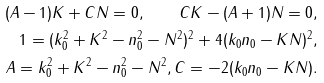Convert formula to latex. <formula><loc_0><loc_0><loc_500><loc_500>( A - 1 ) K + C N = 0 , \quad C K - ( A + 1 ) N = 0 , \\ 1 = ( k _ { 0 } ^ { 2 } + K ^ { 2 } - n _ { 0 } ^ { 2 } - N ^ { 2 } ) ^ { 2 } + 4 ( k _ { 0 } n _ { 0 } - K N ) ^ { 2 } , \\ A = k _ { 0 } ^ { 2 } + K ^ { 2 } - n _ { 0 } ^ { 2 } - N ^ { 2 } , C = - 2 ( k _ { 0 } n _ { 0 } - K N ) .</formula> 